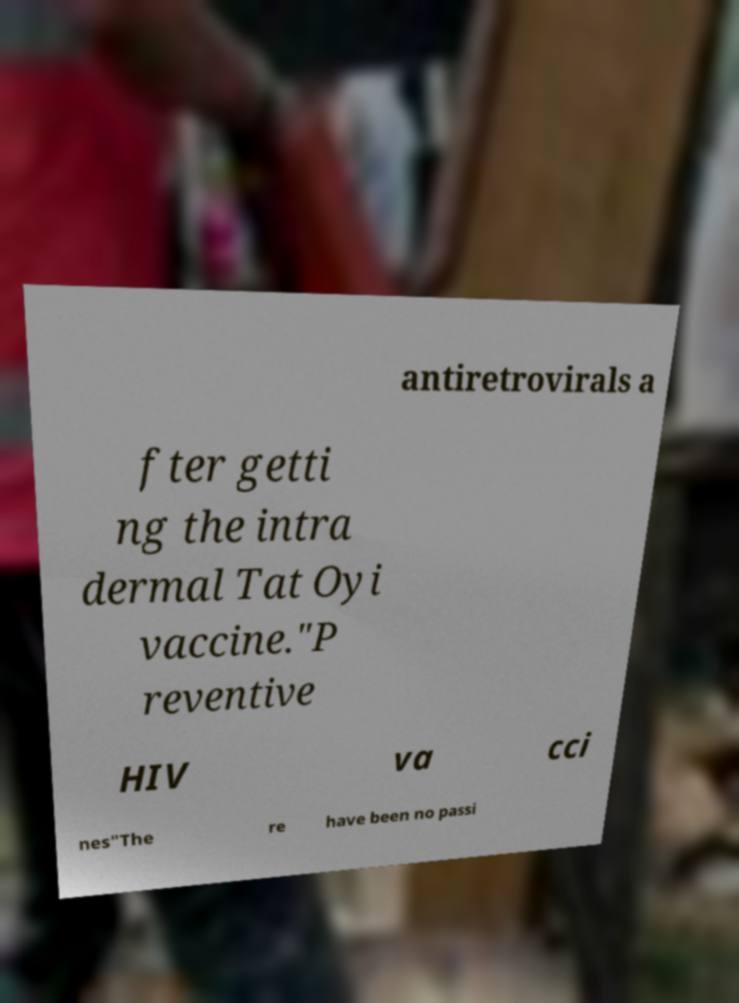Please identify and transcribe the text found in this image. antiretrovirals a fter getti ng the intra dermal Tat Oyi vaccine."P reventive HIV va cci nes"The re have been no passi 